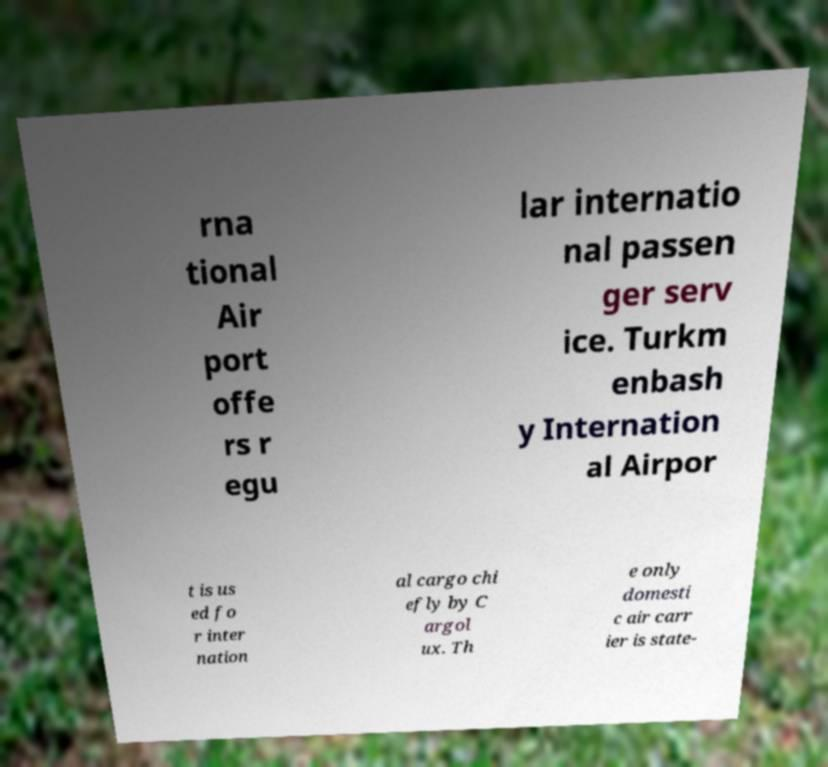What messages or text are displayed in this image? I need them in a readable, typed format. rna tional Air port offe rs r egu lar internatio nal passen ger serv ice. Turkm enbash y Internation al Airpor t is us ed fo r inter nation al cargo chi efly by C argol ux. Th e only domesti c air carr ier is state- 